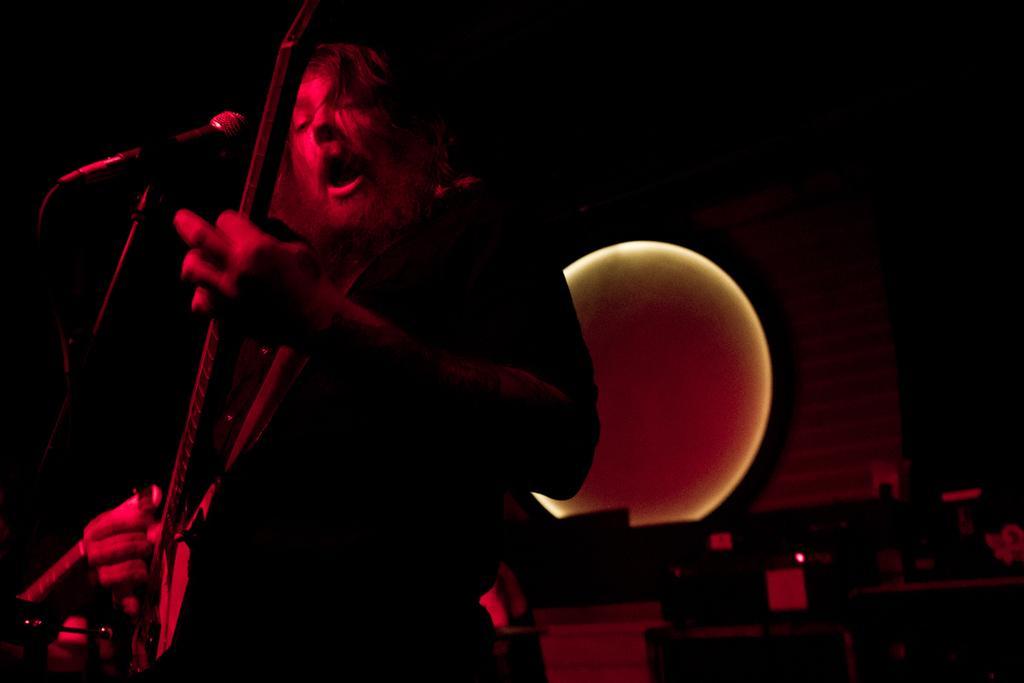Please provide a concise description of this image. In this image we can see a person standing and holding musical instrument in the hands and a mic is placed in front of him. 